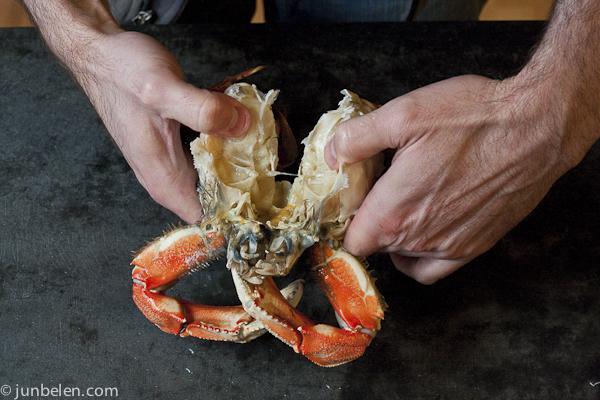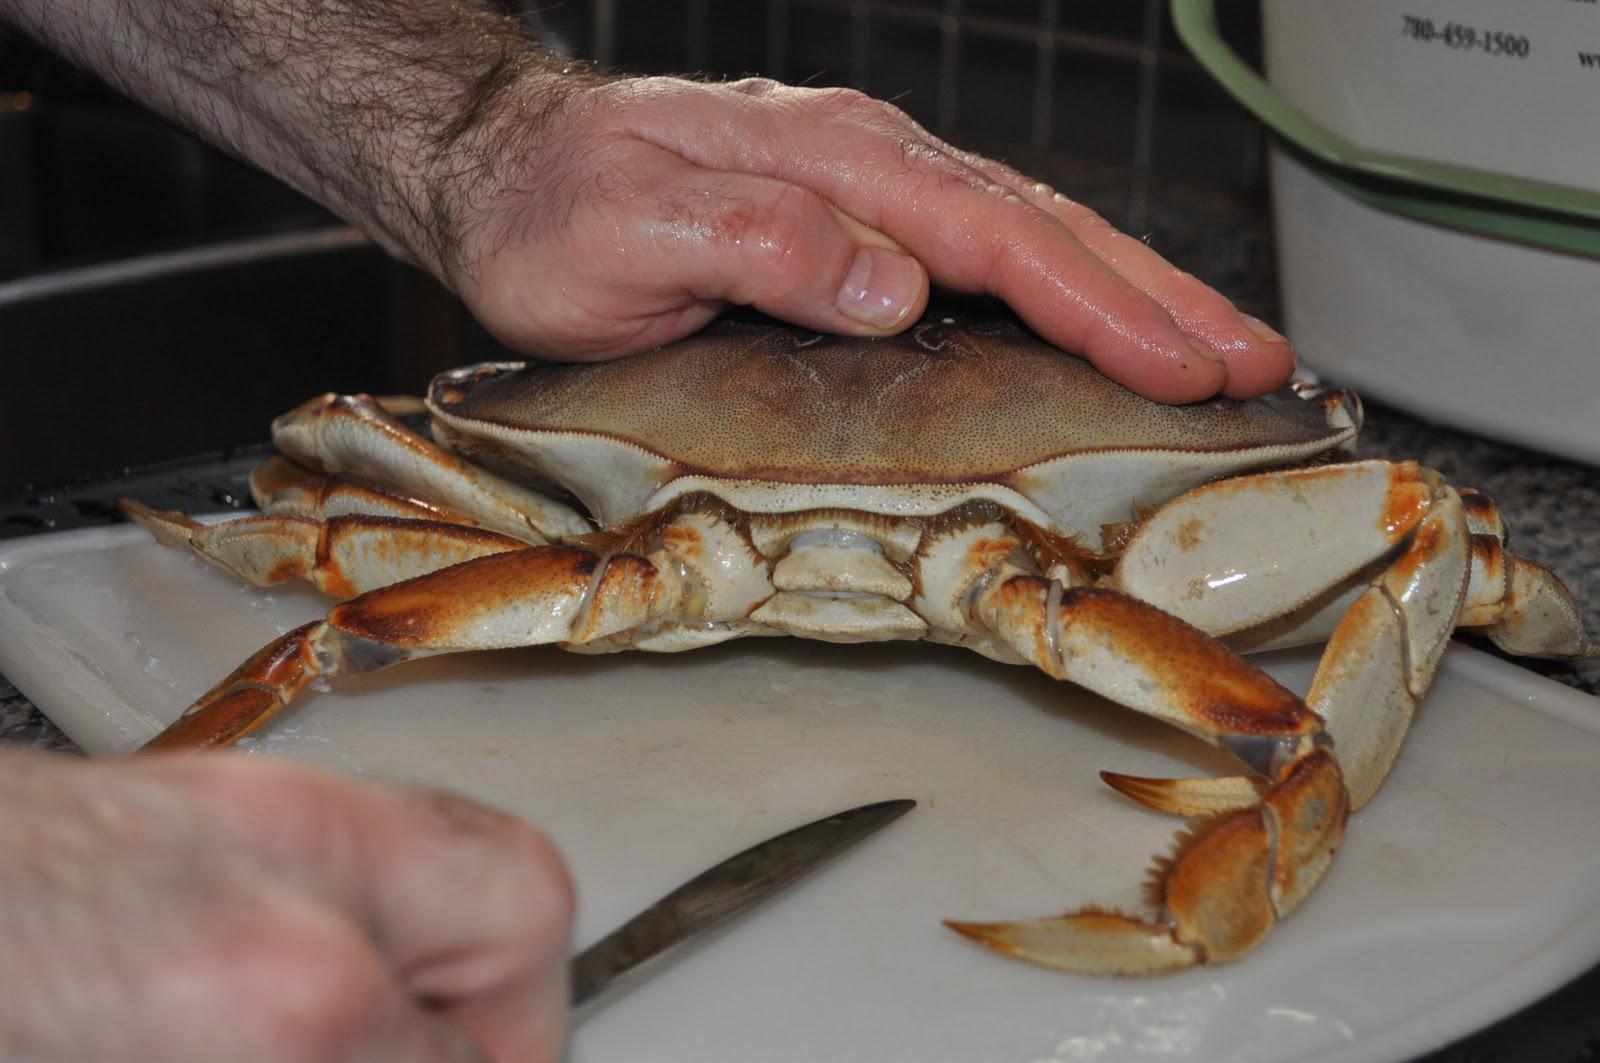The first image is the image on the left, the second image is the image on the right. For the images displayed, is the sentence "One crab is being held by a human." factually correct? Answer yes or no. Yes. The first image is the image on the left, the second image is the image on the right. Examine the images to the left and right. Is the description "One image shows a hand next to the top of an intact crab, and the other image shows two hands tearing a crab in two." accurate? Answer yes or no. Yes. 